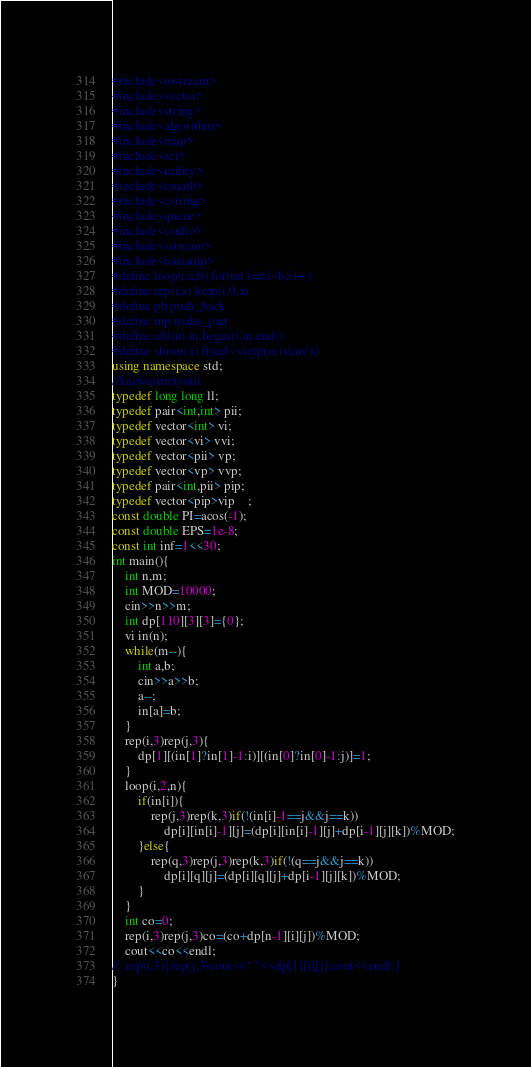Convert code to text. <code><loc_0><loc_0><loc_500><loc_500><_C++_>#include<iostream>
#include<vector>
#include<string>
#include<algorithm>	
#include<map>
#include<set>
#include<utility>
#include<cmath>
#include<cstring>
#include<queue>
#include<cstdio>
#include<sstream>
#include<iomanip>
#define loop(i,a,b) for(int i=a;i<b;i++) 
#define rep(i,a) loop(i,0,a)
#define pb push_back
#define mp make_pair
#define all(in) in.begin(),in.end()
#define shosu(x) fixed<<setprecision(x)
using namespace std;
//kaewasuretyuui
typedef long long ll;
typedef pair<int,int> pii;
typedef vector<int> vi;
typedef vector<vi> vvi;
typedef vector<pii> vp;
typedef vector<vp> vvp;
typedef pair<int,pii> pip;
typedef vector<pip>vip	;
const double PI=acos(-1);
const double EPS=1e-8;
const int inf=1<<30;
int main(){
	int n,m;
	int MOD=10000;
	cin>>n>>m;
	int dp[110][3][3]={0};
	vi in(n);
	while(m--){
		int a,b;
		cin>>a>>b;
		a--;
		in[a]=b;
	}
	rep(i,3)rep(j,3){
		dp[1][(in[1]?in[1]-1:i)][(in[0]?in[0]-1:j)]=1;
	}
	loop(i,2,n){
		if(in[i]){
			rep(j,3)rep(k,3)if(!(in[i]-1==j&&j==k))
				dp[i][in[i]-1][j]=(dp[i][in[i]-1][j]+dp[i-1][j][k])%MOD;
		}else{
			rep(q,3)rep(j,3)rep(k,3)if(!(q==j&&j==k))
				dp[i][q][j]=(dp[i][q][j]+dp[i-1][j][k])%MOD;
		}
	}
	int co=0;
	rep(i,3)rep(j,3)co=(co+dp[n-1][i][j])%MOD;
	cout<<co<<endl;
//	rep(i,3){rep(j,3)cout<<" "<<dp[1][i][j];cout<<endl;}
}</code> 